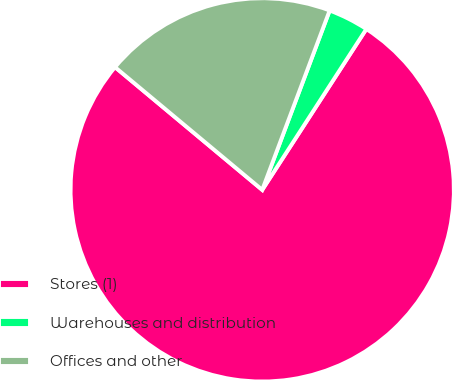Convert chart to OTSL. <chart><loc_0><loc_0><loc_500><loc_500><pie_chart><fcel>Stores (1)<fcel>Warehouses and distribution<fcel>Offices and other<nl><fcel>76.92%<fcel>3.42%<fcel>19.66%<nl></chart> 